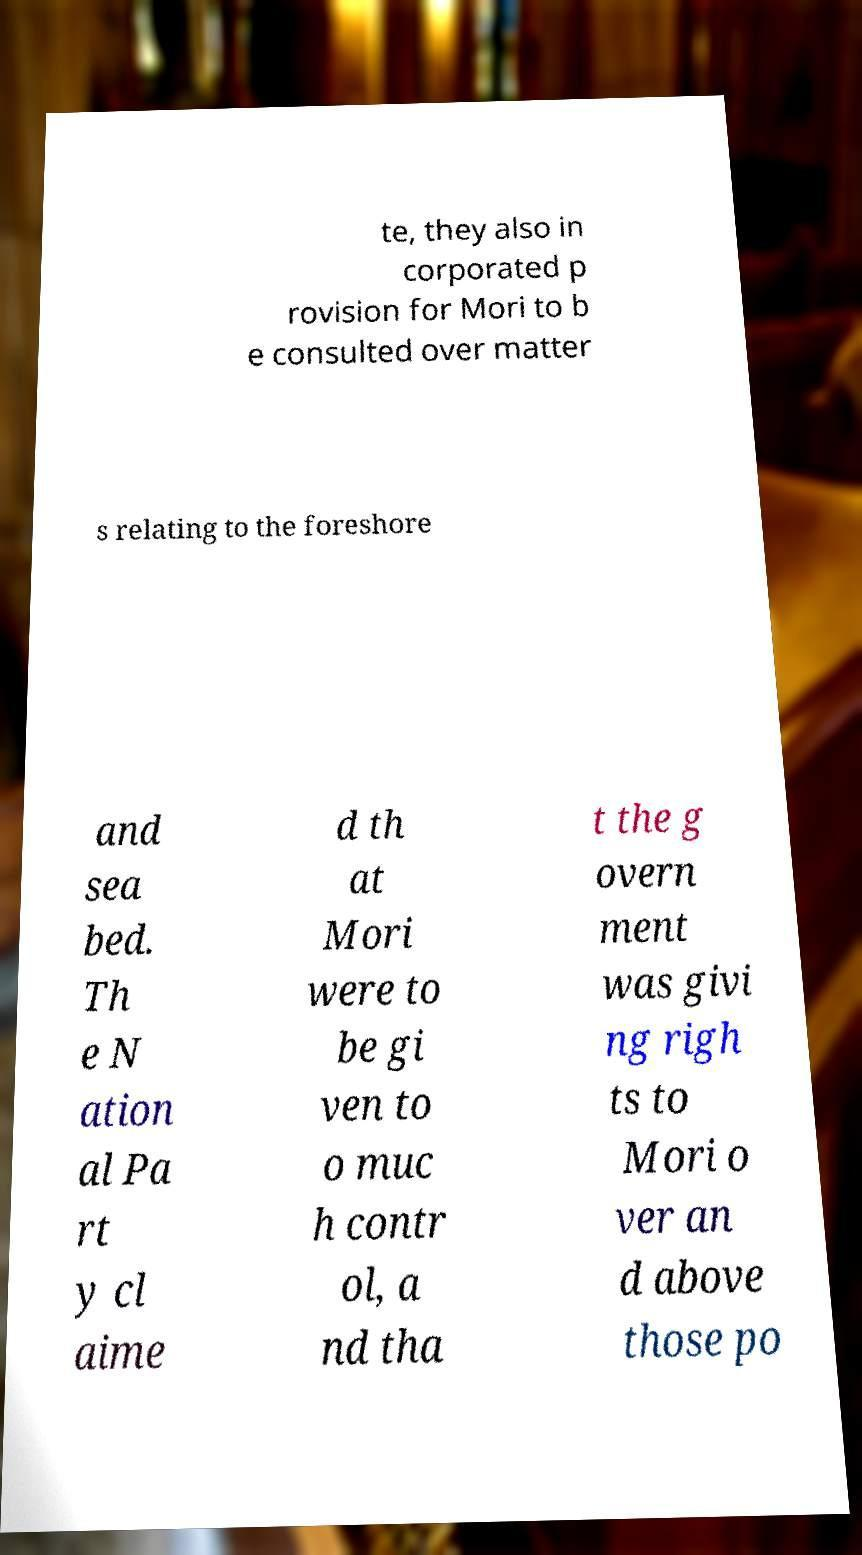Could you extract and type out the text from this image? te, they also in corporated p rovision for Mori to b e consulted over matter s relating to the foreshore and sea bed. Th e N ation al Pa rt y cl aime d th at Mori were to be gi ven to o muc h contr ol, a nd tha t the g overn ment was givi ng righ ts to Mori o ver an d above those po 